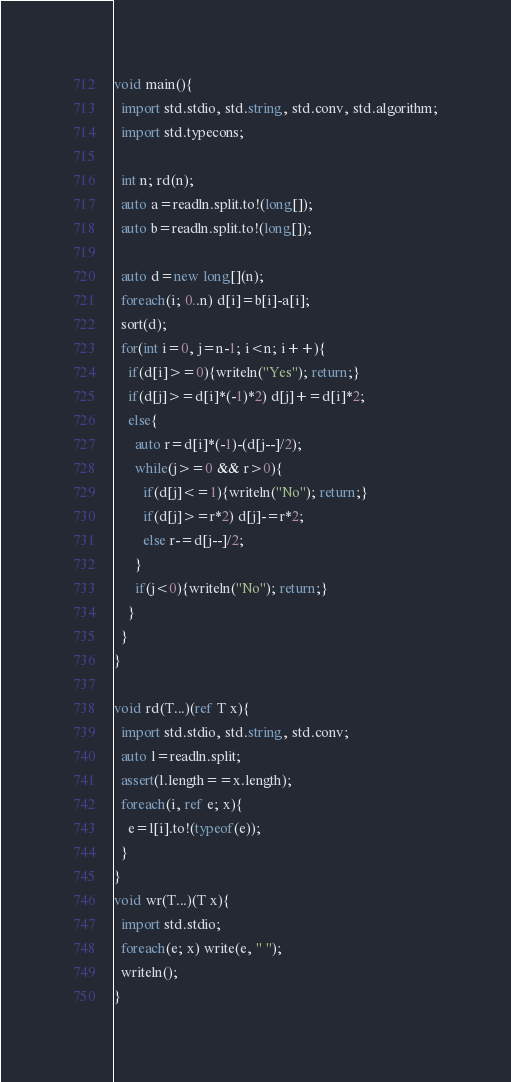Convert code to text. <code><loc_0><loc_0><loc_500><loc_500><_D_>void main(){
  import std.stdio, std.string, std.conv, std.algorithm;
  import std.typecons;

  int n; rd(n);
  auto a=readln.split.to!(long[]);
  auto b=readln.split.to!(long[]);

  auto d=new long[](n);
  foreach(i; 0..n) d[i]=b[i]-a[i];
  sort(d);
  for(int i=0, j=n-1; i<n; i++){
    if(d[i]>=0){writeln("Yes"); return;}
    if(d[j]>=d[i]*(-1)*2) d[j]+=d[i]*2;
    else{
      auto r=d[i]*(-1)-(d[j--]/2);
      while(j>=0 && r>0){
        if(d[j]<=1){writeln("No"); return;}
        if(d[j]>=r*2) d[j]-=r*2;
        else r-=d[j--]/2;
      }
      if(j<0){writeln("No"); return;}
    }
  }
}

void rd(T...)(ref T x){
  import std.stdio, std.string, std.conv;
  auto l=readln.split;
  assert(l.length==x.length);
  foreach(i, ref e; x){
    e=l[i].to!(typeof(e));
  }
}
void wr(T...)(T x){
  import std.stdio;
  foreach(e; x) write(e, " ");
  writeln();
}</code> 